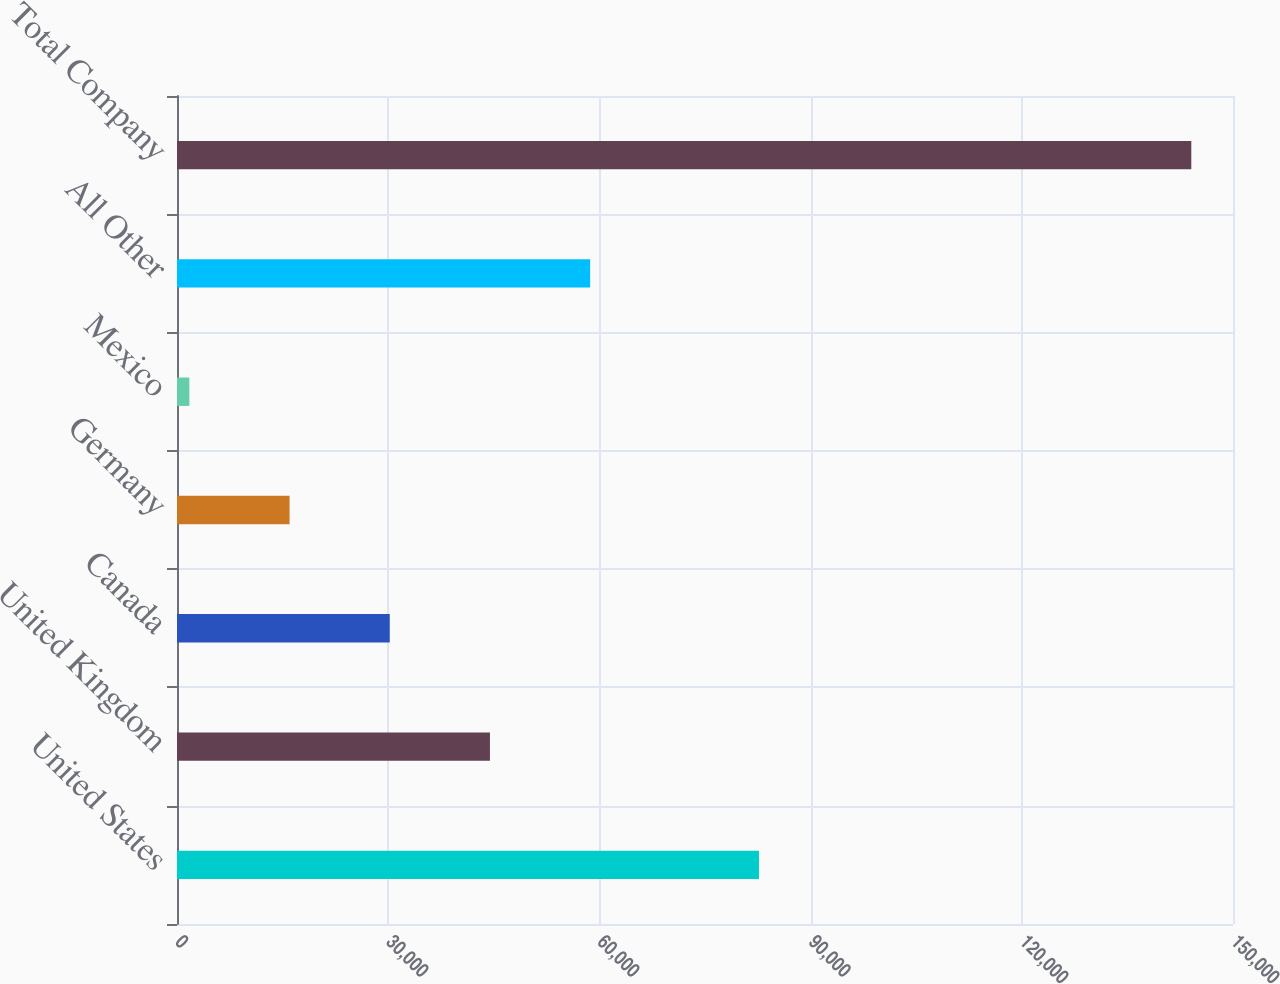<chart> <loc_0><loc_0><loc_500><loc_500><bar_chart><fcel>United States<fcel>United Kingdom<fcel>Canada<fcel>Germany<fcel>Mexico<fcel>All Other<fcel>Total Company<nl><fcel>82665<fcel>44453<fcel>30221<fcel>15989<fcel>1757<fcel>58685<fcel>144077<nl></chart> 